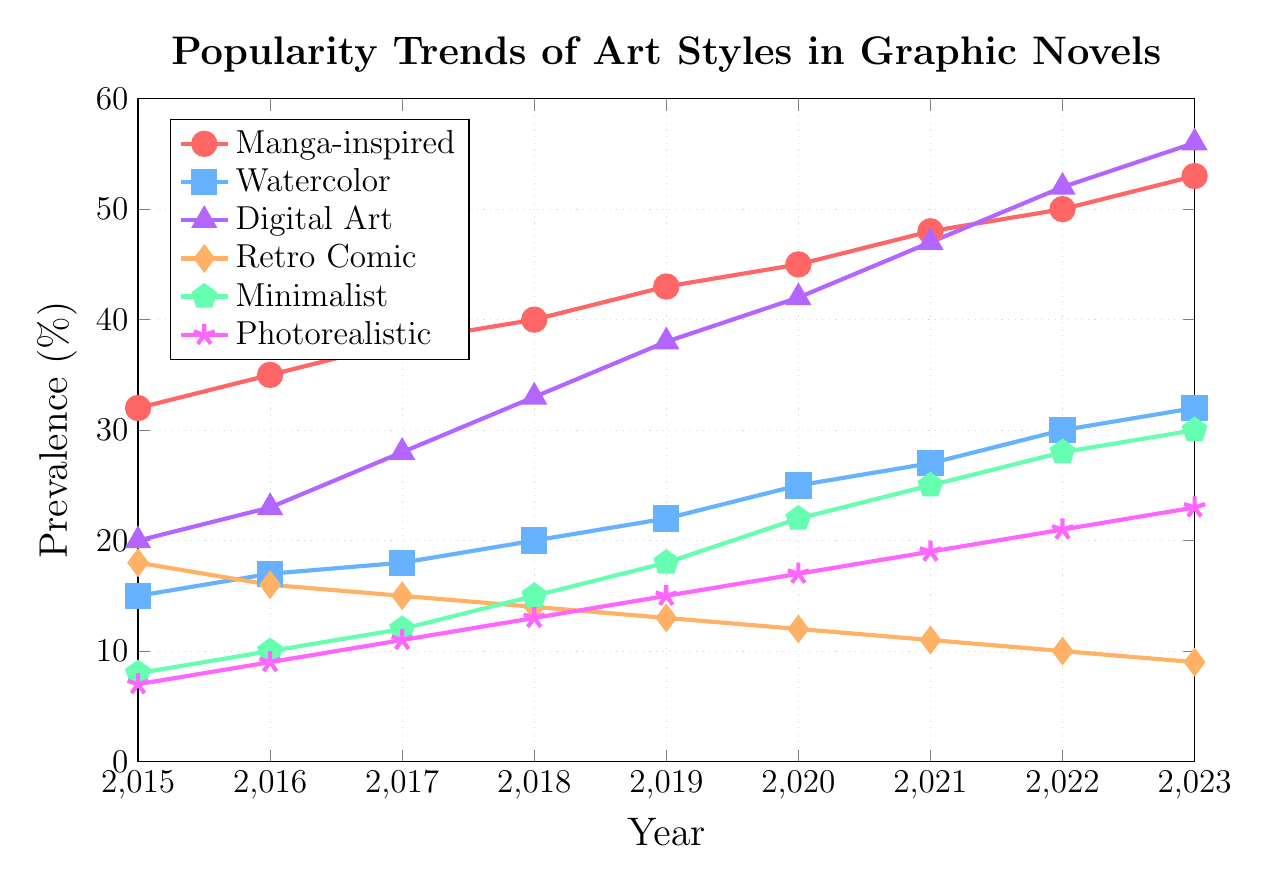what's the most prevalent art style in 2023? In 2023, the "Digital Art" style reaches a value of 56. This is the highest value among all art styles presented in the figure for that year.
Answer: Digital Art which year did "Digital Art" surpass the 40% mark? Examine the points where "Digital Art" exceeds 40%. This happens in 2020 when it reaches a value of 42%.
Answer: 2020 how many percentage points did "Watercolor" style increase from 2015 to 2023? The prevalence of the "Watercolor" style in 2015 is 15%, and in 2023, it is 32%. The increase is calculated by subtracting the initial value from the final value: 32% - 15% = 17%.
Answer: 17% is the trend of "Manga-inspired" consistently upward? Reviewing each year for "Manga-inspired", we see increases every year from 2015 (32%) to 2023 (53%). No year shows a decrease.
Answer: Yes compare the prevalence of "Minimalist" style in 2018 and 2021 The "Minimalist" style is at 15% in 2018 and increases to 25% in 2021. Comparing the values, the increase from 15% to 25% signifies a growth of 10 percentage points.
Answer: Increased by 10% which art style decreased the most between 2015 and 2023? By comparing the initial and final values for each style, only "Retro Comic" shows a decrease. It drops from 18% in 2015 to 9% in 2023, a decrease of 9 percentage points.
Answer: Retro Comic what's the average prevalence of "Photorealistic" from 2015 to 2023? Sum the values for "Photorealistic" from 2015 to 2023 and divide by the number of years. (7 + 9 + 11 + 13 + 15 + 17 + 19 + 21 + 23) / 9 = 15.
Answer: 15 which art style had the most significant growth in percentage points from 2015 to 2023? Calculate each style's growth by subtracting its 2015 value from its 2023 value. Digital Art shows the largest growth: 56% - 20% = 36 percentage points.
Answer: Digital Art did any art style show steady growth without any decline between 2015 and 2023? By checking all the styles, both "Manga-inspired" and "Digital Art" show consistent increases every year from 2015 to 2023 without any decline.
Answer: Manga-inspired, Digital Art compare the trends of "Retro Comic" and "Minimalist" from 2015 to 2023 "Retro Comic" follows a steady downward trend from 18% in 2015 to 9% in 2023, while "Minimalist" increases from 8% in 2015 to 30% in 2023. The trends are inverse: one is decreasing, the other is increasing.
Answer: Inverse trends 